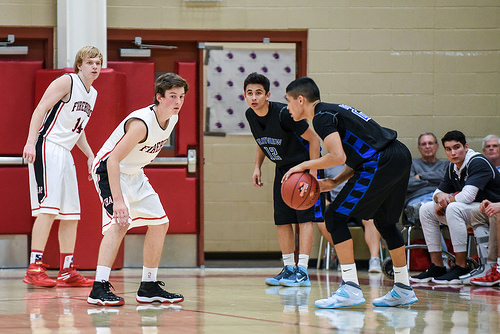<image>
Is the boy to the left of the boy? No. The boy is not to the left of the boy. From this viewpoint, they have a different horizontal relationship. Is the man behind the chair? No. The man is not behind the chair. From this viewpoint, the man appears to be positioned elsewhere in the scene. 